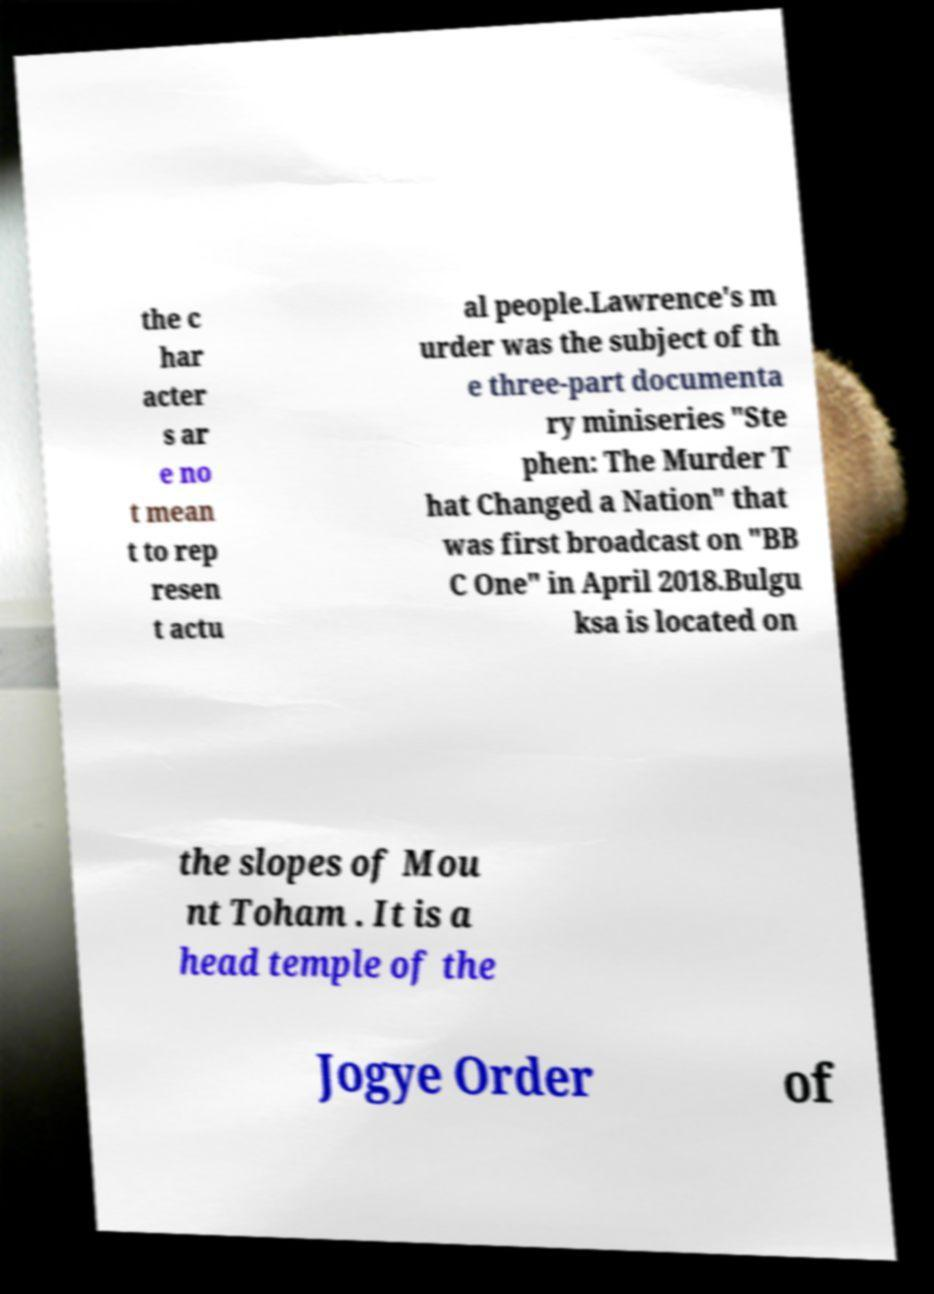What messages or text are displayed in this image? I need them in a readable, typed format. the c har acter s ar e no t mean t to rep resen t actu al people.Lawrence's m urder was the subject of th e three-part documenta ry miniseries "Ste phen: The Murder T hat Changed a Nation" that was first broadcast on "BB C One" in April 2018.Bulgu ksa is located on the slopes of Mou nt Toham . It is a head temple of the Jogye Order of 